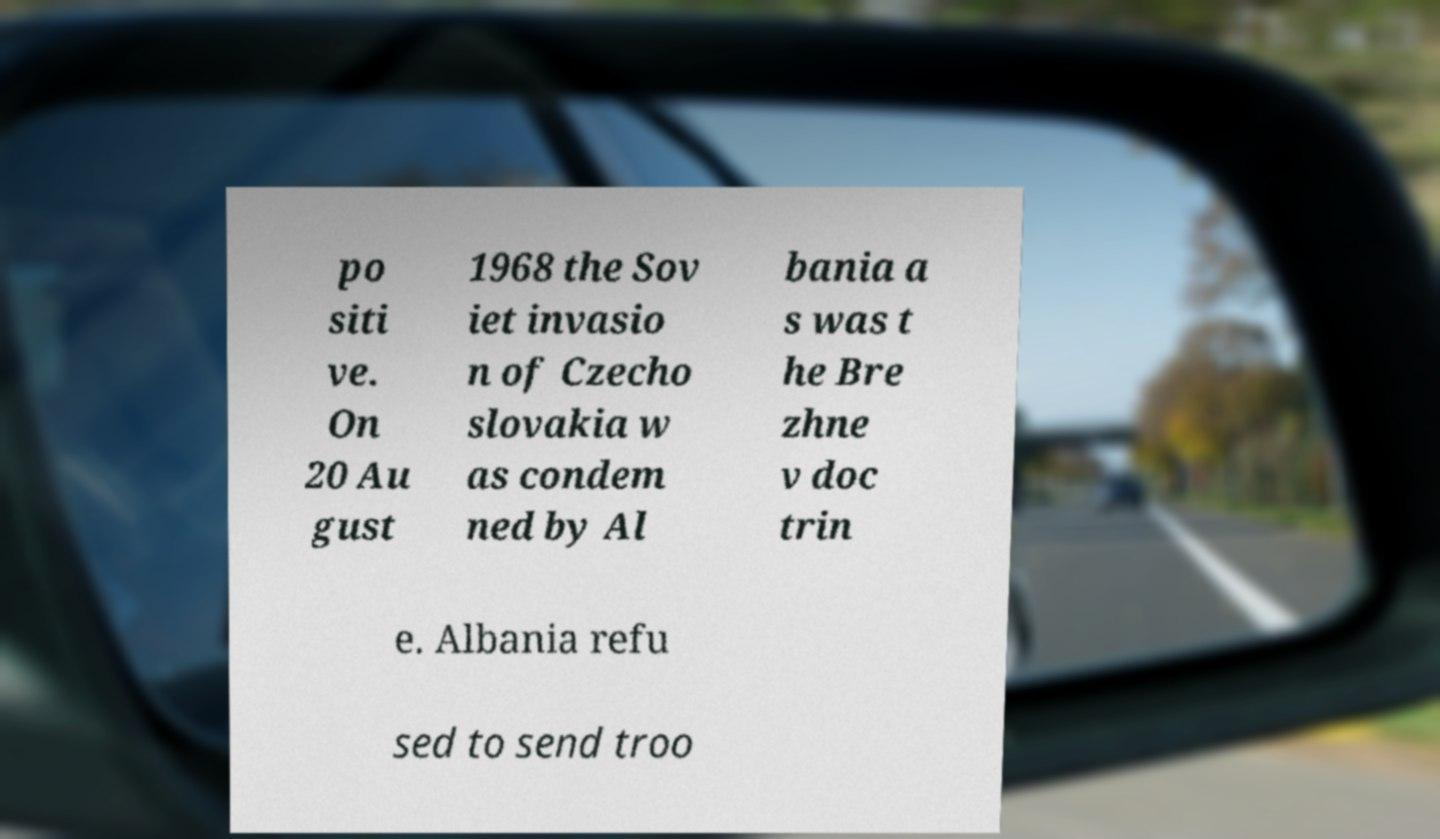Could you extract and type out the text from this image? po siti ve. On 20 Au gust 1968 the Sov iet invasio n of Czecho slovakia w as condem ned by Al bania a s was t he Bre zhne v doc trin e. Albania refu sed to send troo 